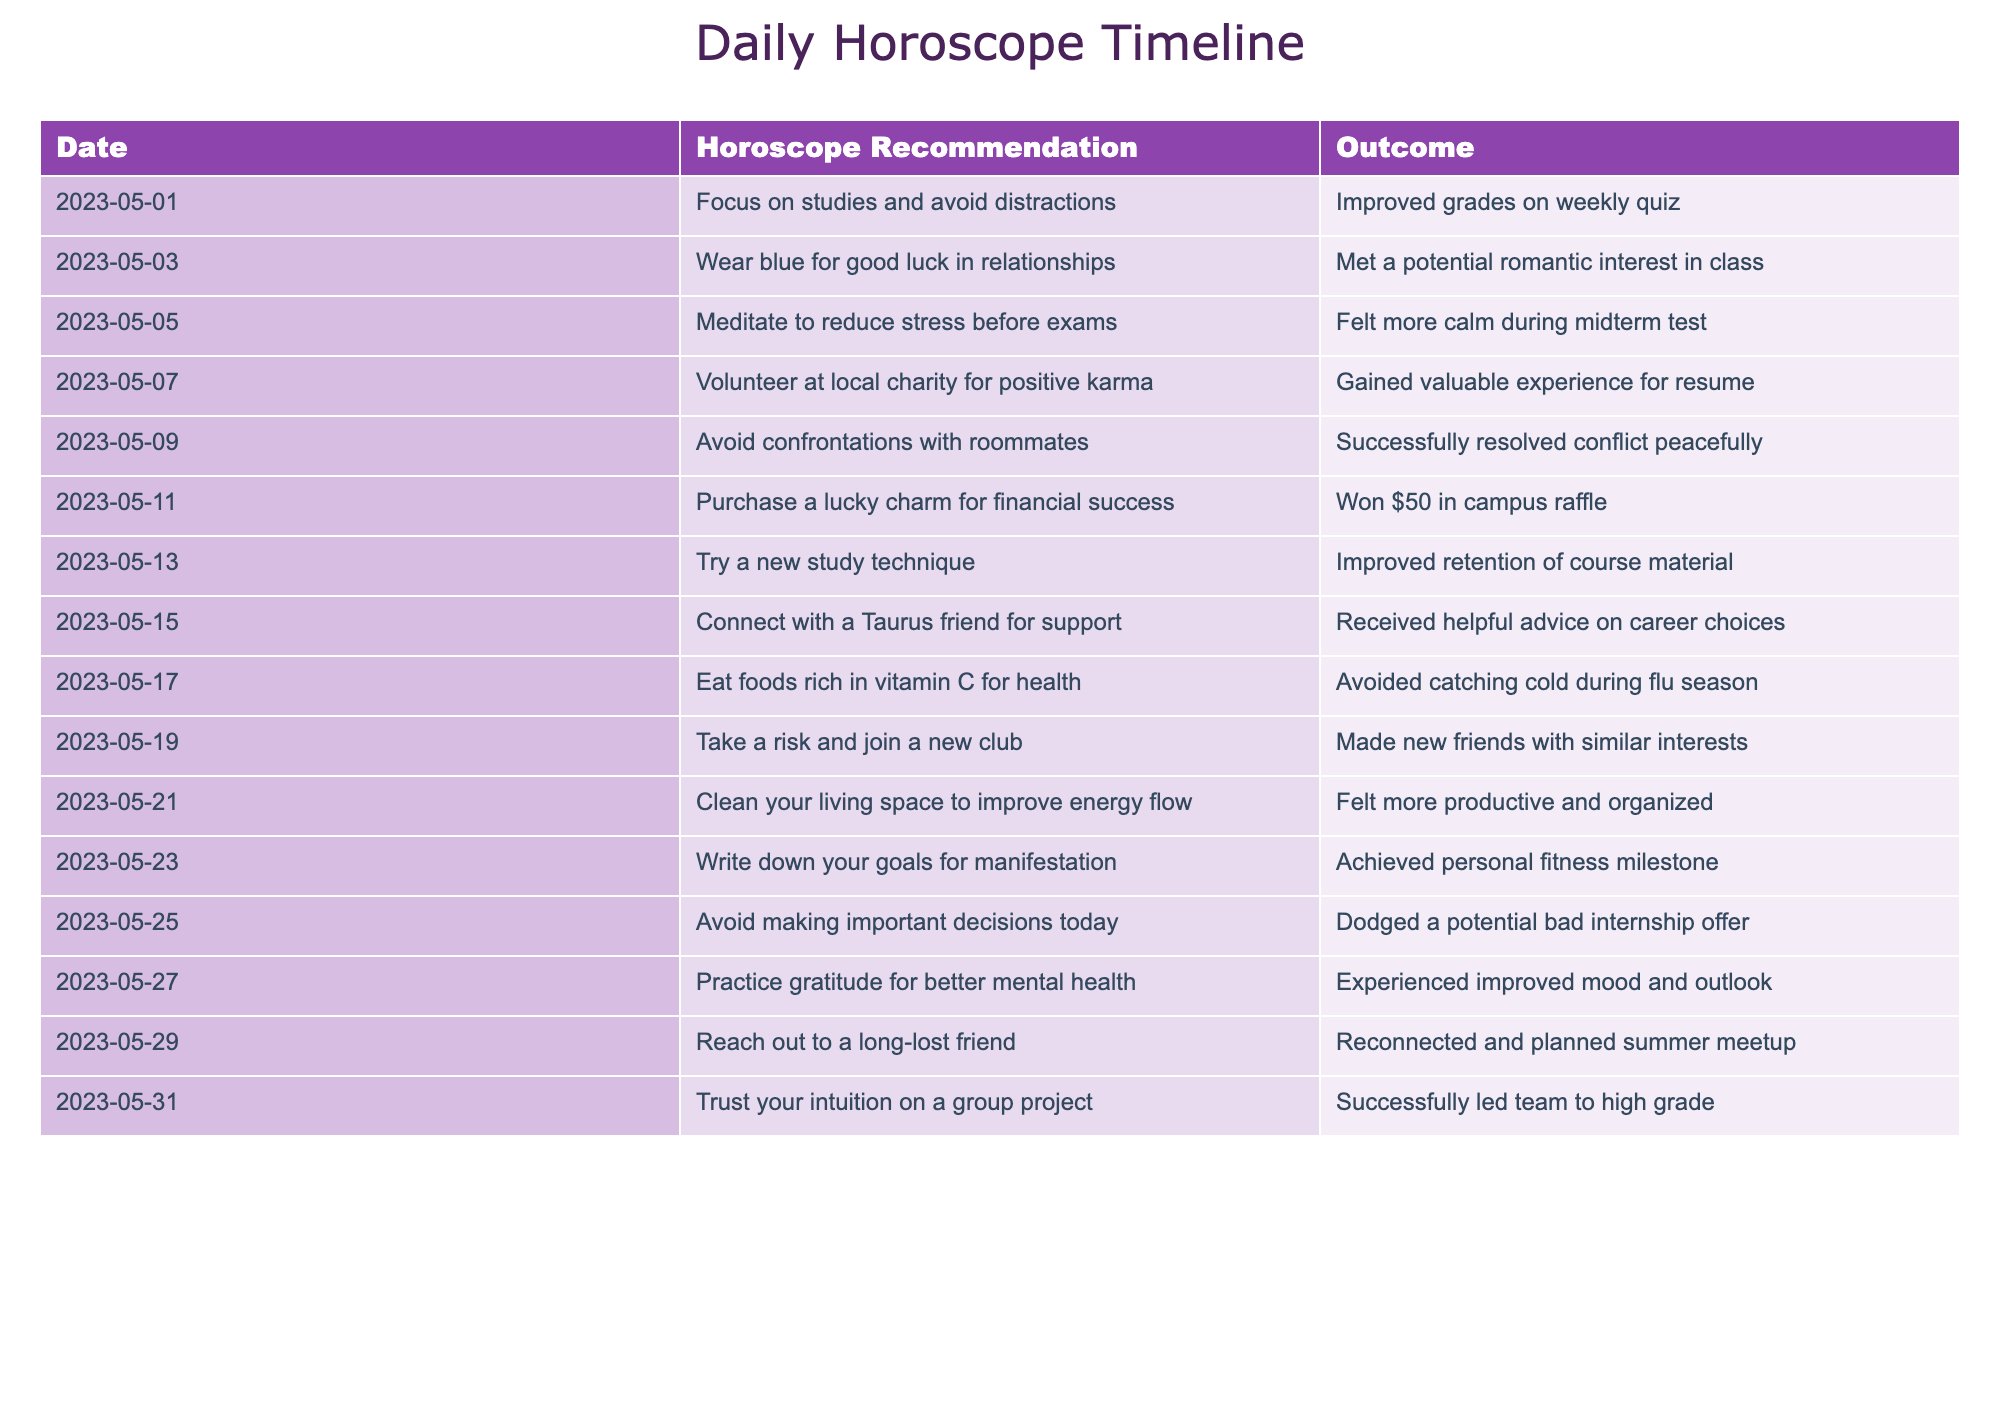What was the outcome of wearing blue on May 3rd? The table indicates that on May 3rd, the horoscope recommendation was to wear blue for good luck in relationships, and the outcome was meeting a potential romantic interest in class. This shows a direct correlation between the recommendation and the positive experience.
Answer: Met a potential romantic interest in class Did the advice on May 25th lead to a positive or negative outcome? On May 25th, the horoscope recommendation was to avoid making important decisions. The outcome reported was dodging a potential bad internship offer, which indicates that following this advice helped prevent a negative situation.
Answer: Positive outcome What were the outcomes for recommendations related to health? The recommendations related to health are on May 17th (to eat foods rich in vitamin C) and May 5th (to meditate to reduce stress). The outcomes were avoiding catching a cold and feeling calm during the midterm test, respectively. Both outcomes reflect positive health benefits.
Answer: Positive health outcomes What is the total number of recommendations that resulted in a positive outcome from this timeline? By checking each outcome in the table, it is clear that all listed outcomes were positive (14 in total). Therefore, since there are no negative outcomes recorded, the total is simply the count of all the dates listed.
Answer: 14 Which recommendation had the most significant impact on academic performance? The recommendation on May 1st was to focus on studies and avoid distractions, resulting in improved grades on a weekly quiz. Although others suggested new study techniques and meditation for stress relief, the direct improvement in quiz grades signifies significant academic impact from the May 1st advice.
Answer: Focus on studies How did connecting with a Taurus friend influence decision-making? On May 15th, the advice was to connect with a Taurus friend for support, which is evidenced by receiving helpful advice on career choices. This interaction potentially influenced decision-making positively, as the friend provided valuable insight.
Answer: Positive influence on decision-making Was there a recommendation that specifically mentioned improving organization? Yes, on May 21st, the recommendation was to clean your living space to improve energy flow. The outcome indicated feeling more productive and organized, confirming that it was an effective approach for enhancing organization.
Answer: Yes Which two recommendations are related to achieving personal goals? The recommendations related to personal goals are on May 23rd (writing down goals for manifestation) which led to achieving a personal fitness milestone, and on May 5th (meditating to reduce stress) which contributed to feeling calm during exams. Both pertain to personal growth and achievement.
Answer: May 23rd and May 5th 